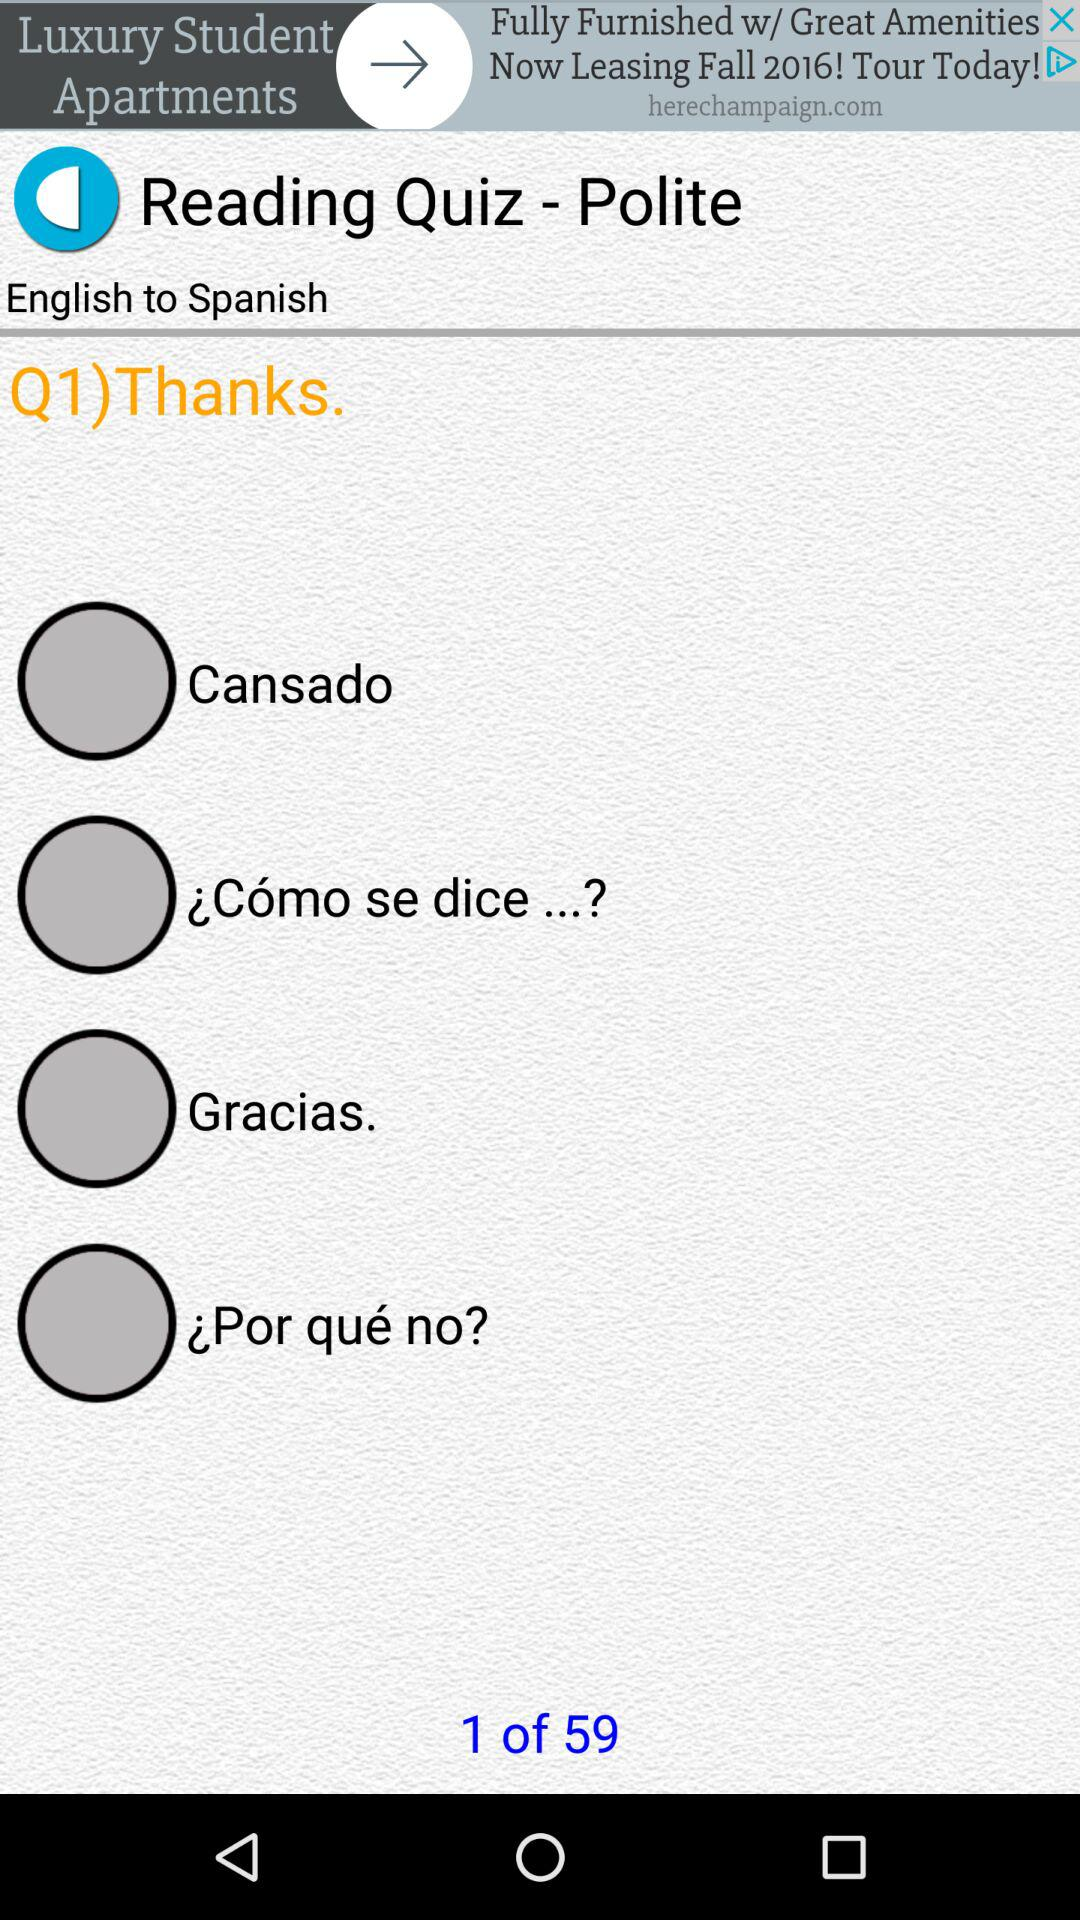How many questions in total are there? There are 59 questions. 